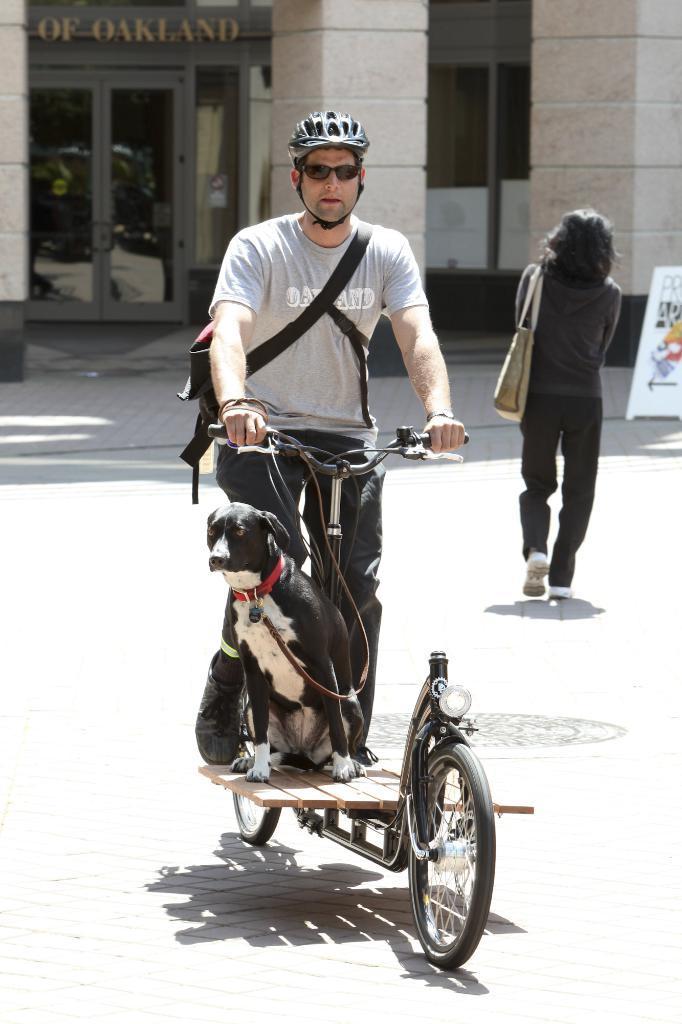Can you describe this image briefly? A person is riding bicycle and a dog is also on the bicycle. In the background a woman is walking and carrying bag on her shoulders and there are doors and a building and a hoarding. 